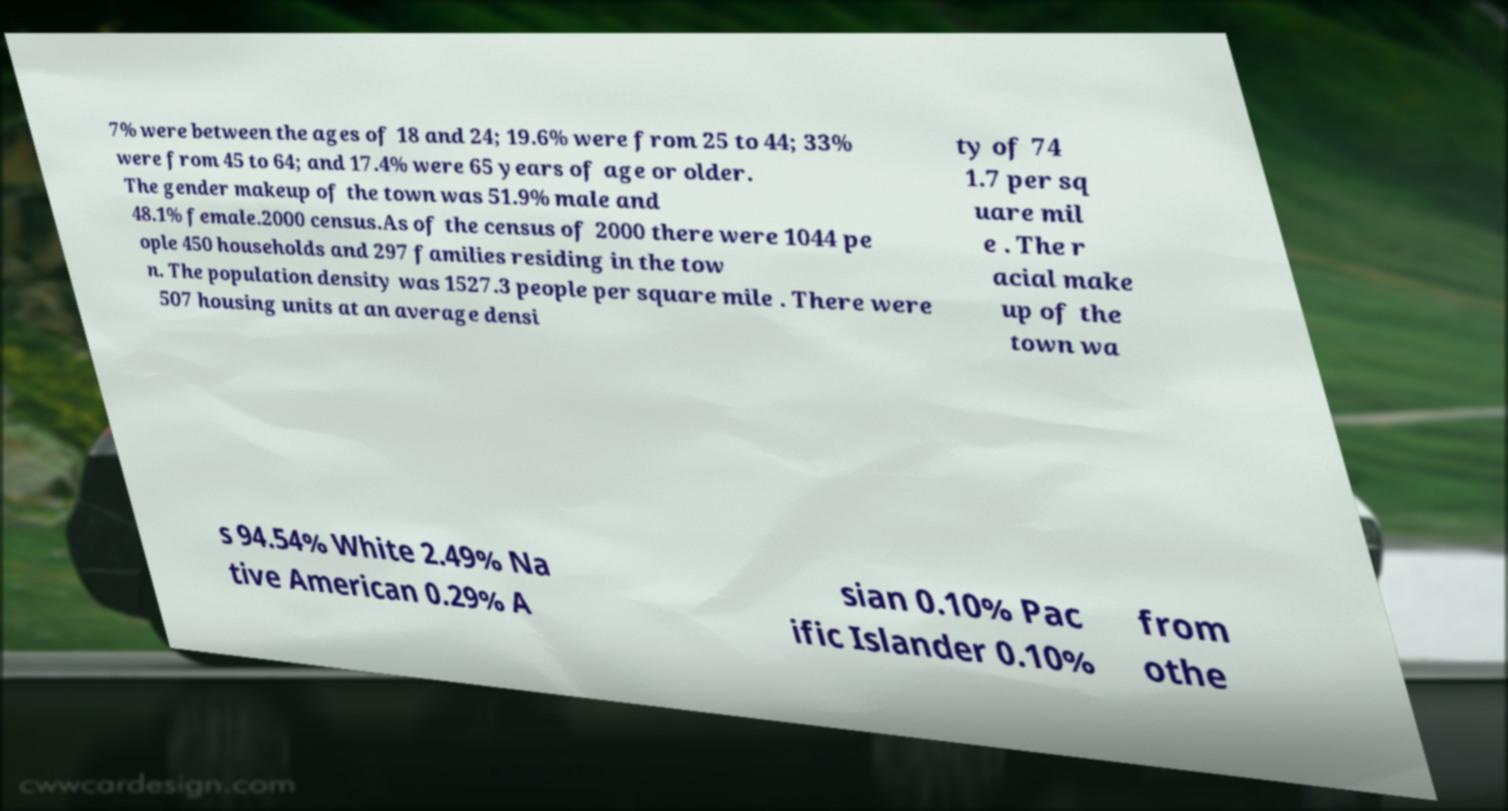Can you accurately transcribe the text from the provided image for me? 7% were between the ages of 18 and 24; 19.6% were from 25 to 44; 33% were from 45 to 64; and 17.4% were 65 years of age or older. The gender makeup of the town was 51.9% male and 48.1% female.2000 census.As of the census of 2000 there were 1044 pe ople 450 households and 297 families residing in the tow n. The population density was 1527.3 people per square mile . There were 507 housing units at an average densi ty of 74 1.7 per sq uare mil e . The r acial make up of the town wa s 94.54% White 2.49% Na tive American 0.29% A sian 0.10% Pac ific Islander 0.10% from othe 